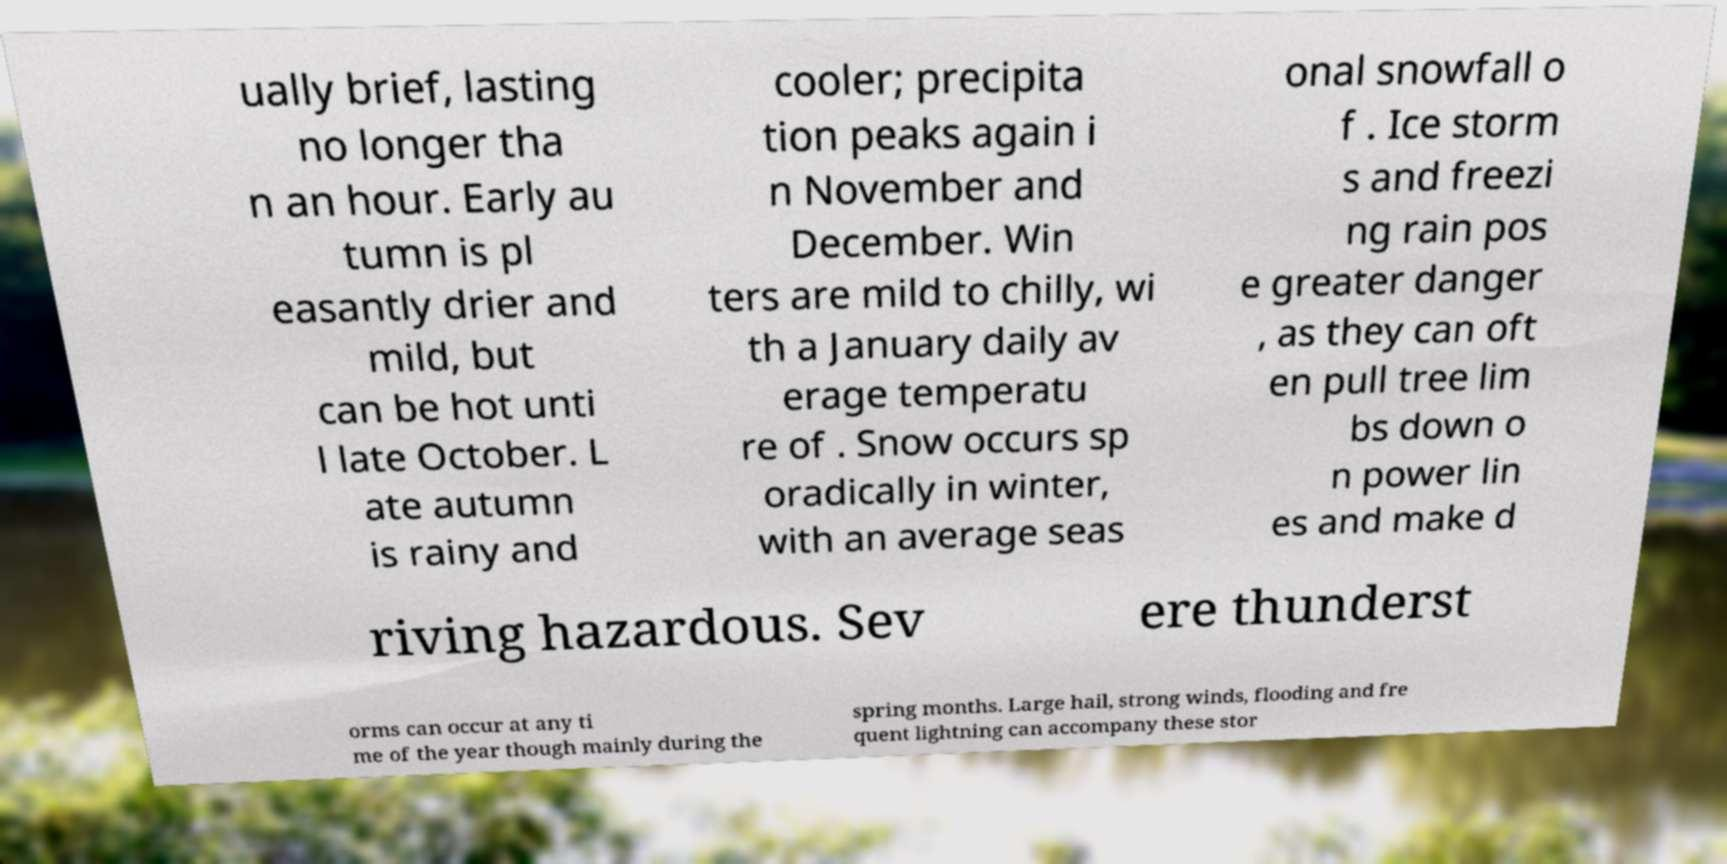There's text embedded in this image that I need extracted. Can you transcribe it verbatim? ually brief, lasting no longer tha n an hour. Early au tumn is pl easantly drier and mild, but can be hot unti l late October. L ate autumn is rainy and cooler; precipita tion peaks again i n November and December. Win ters are mild to chilly, wi th a January daily av erage temperatu re of . Snow occurs sp oradically in winter, with an average seas onal snowfall o f . Ice storm s and freezi ng rain pos e greater danger , as they can oft en pull tree lim bs down o n power lin es and make d riving hazardous. Sev ere thunderst orms can occur at any ti me of the year though mainly during the spring months. Large hail, strong winds, flooding and fre quent lightning can accompany these stor 